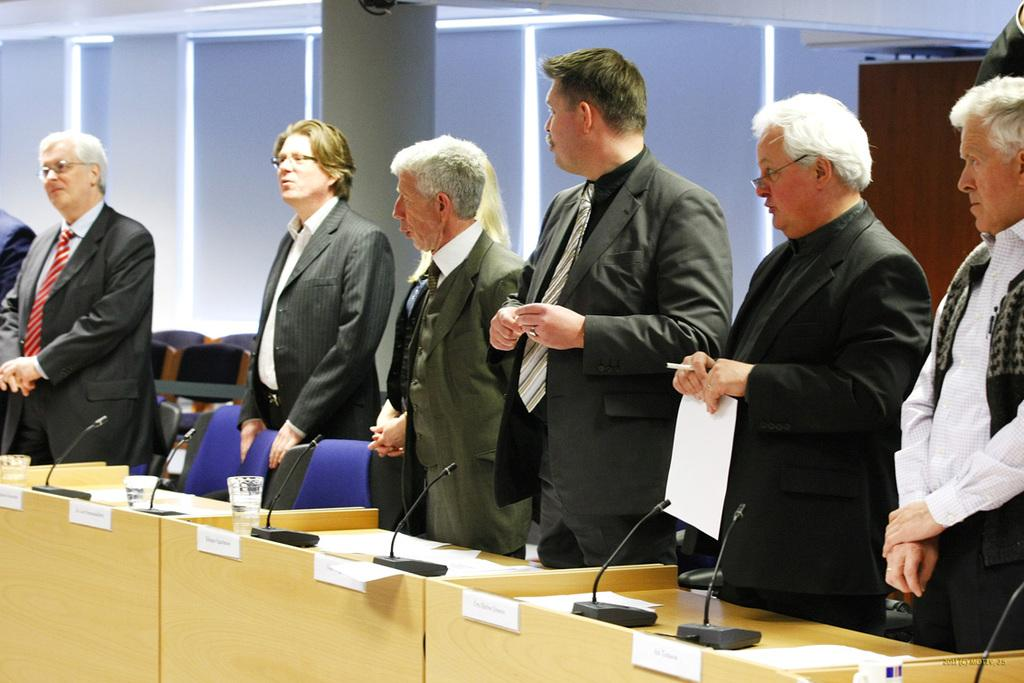How many people are in the image? There is a group of people in the image, but the exact number is not specified. What are the people wearing in the image? The people are wearing blazers and ties in the image. What are the people doing in the image? The people are standing in the image. What objects are in front of the group? There are microphones, glasses, and chairs in front of the group. What can be seen in the background of the image? There are pillars and a wall in the background of the image. How many bees are buzzing around the people in the image? There are no bees present in the image. What type of snakes are slithering on the floor near the group? There are no snakes present in the image. 